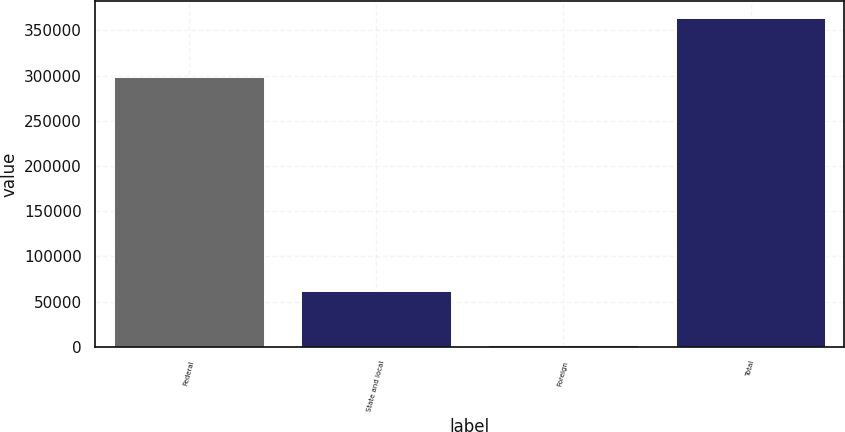Convert chart to OTSL. <chart><loc_0><loc_0><loc_500><loc_500><bar_chart><fcel>Federal<fcel>State and local<fcel>Foreign<fcel>Total<nl><fcel>298991<fcel>62232<fcel>2293<fcel>364177<nl></chart> 